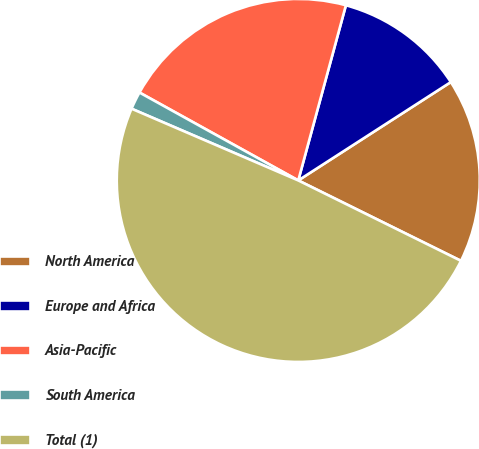Convert chart to OTSL. <chart><loc_0><loc_0><loc_500><loc_500><pie_chart><fcel>North America<fcel>Europe and Africa<fcel>Asia-Pacific<fcel>South America<fcel>Total (1)<nl><fcel>16.42%<fcel>11.66%<fcel>21.18%<fcel>1.58%<fcel>49.16%<nl></chart> 